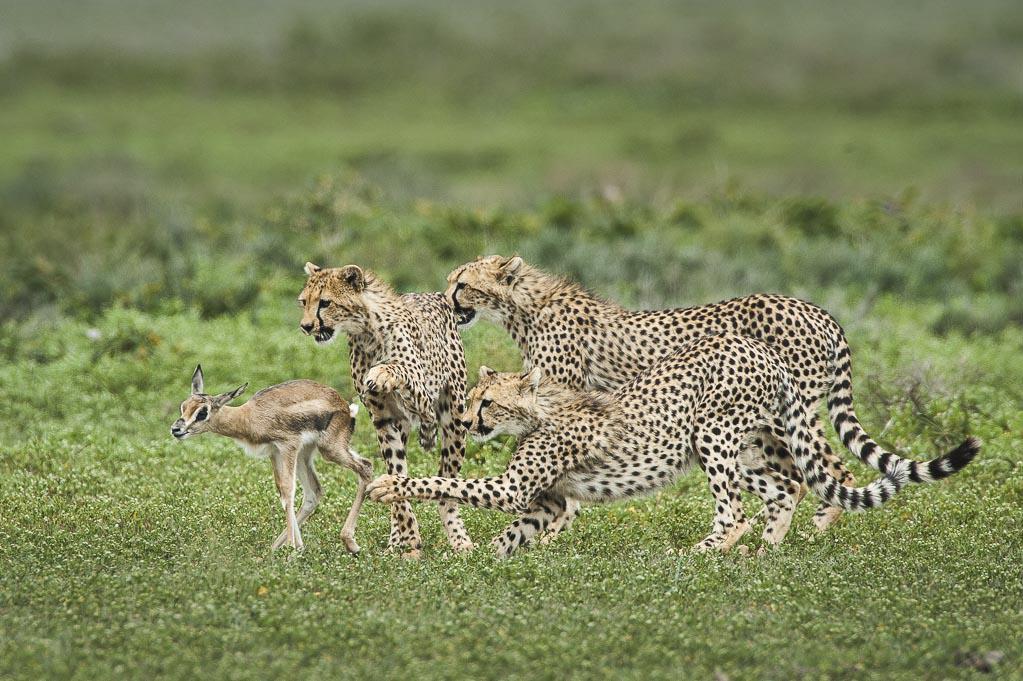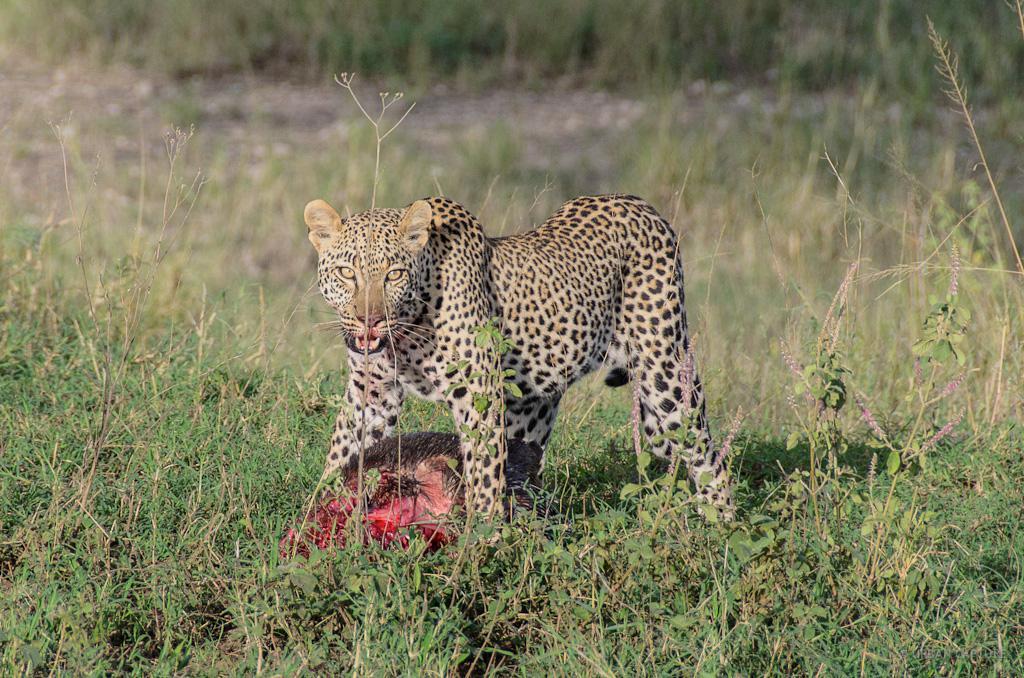The first image is the image on the left, the second image is the image on the right. Considering the images on both sides, is "There are at least four leopards." valid? Answer yes or no. Yes. The first image is the image on the left, the second image is the image on the right. Examine the images to the left and right. Is the description "Each image contains a single cheetah, with one image showing a rightward facing cheetah, and the other showing a forward-looking cheetah." accurate? Answer yes or no. No. 